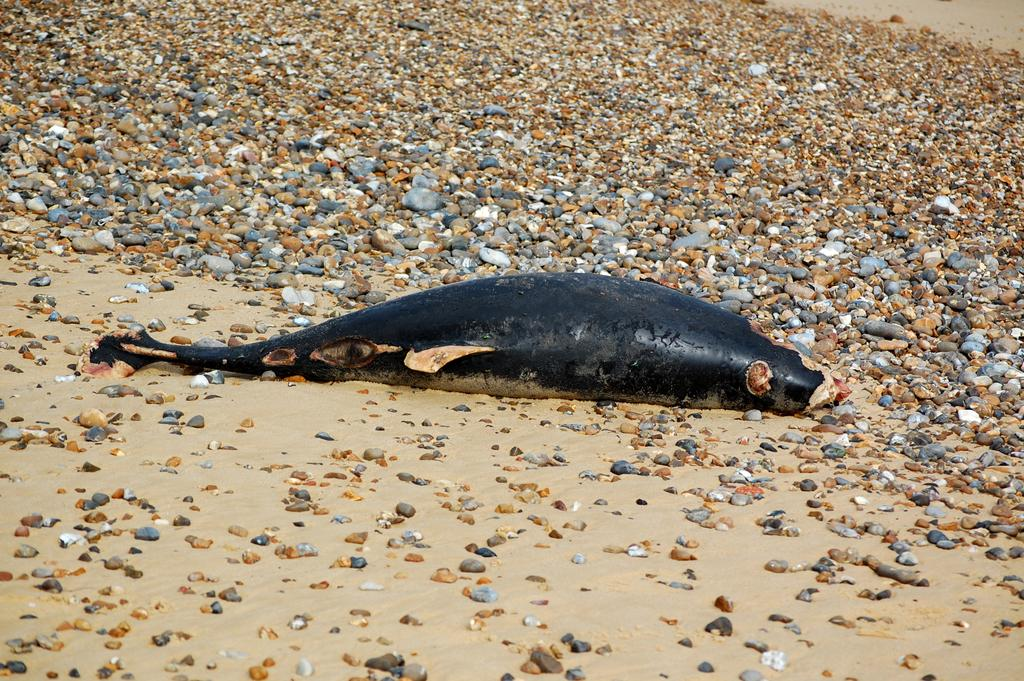What type of surface is visible in the image? The image contains a surface with stones. What can be seen on the surface? There is a fish on the surface. What is the color of the fish? The fish is black in color. What type of fuel is being used by the fish in the image? There is no fuel present in the image, as fish do not require fuel to function. 